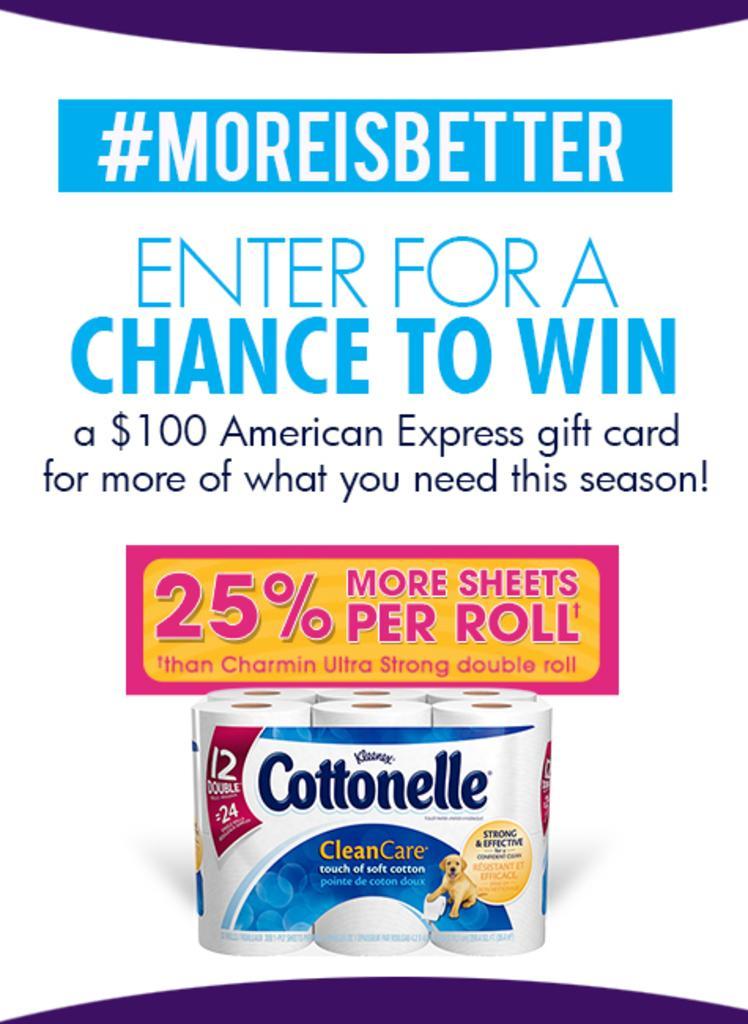Could you give a brief overview of what you see in this image? In this image there is a poster with a picture of napkins with some text on it. 